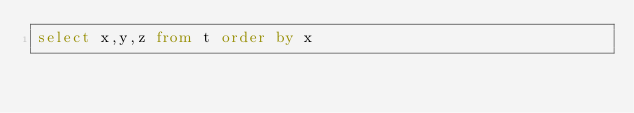<code> <loc_0><loc_0><loc_500><loc_500><_SQL_>select x,y,z from t order by x</code> 